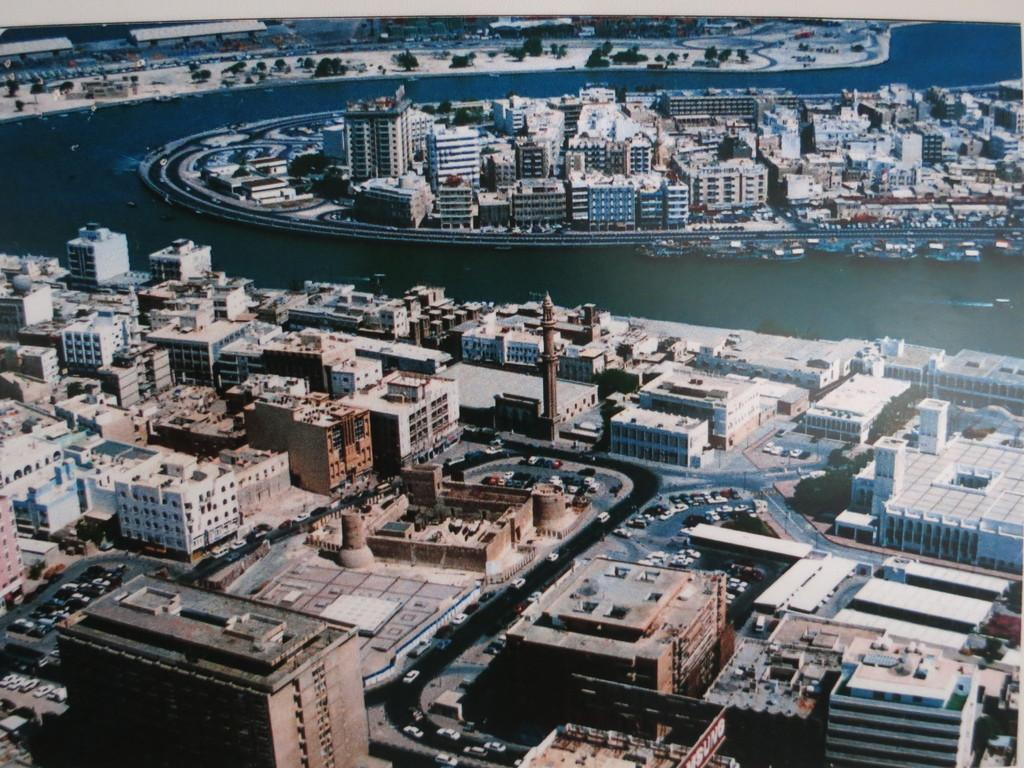What type of structures can be seen in the image? There are buildings in the image. What can be found alongside the buildings? There are roads in the image. What mode of transportation is present in the image? There are cars in the image. What natural feature is visible in the image? There is a sea visible in the image. Can you describe the unique placement of some buildings in the image? There are buildings in the middle of the sea. What type of knee is visible in the image? There is no knee present in the image. What type of trousers are the buildings wearing in the image? Buildings do not wear trousers; they are inanimate structures. 